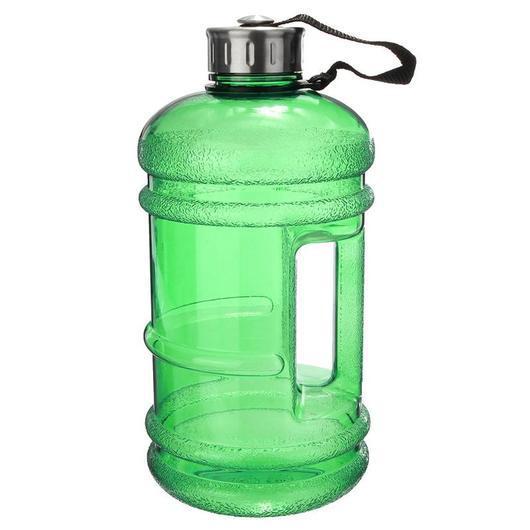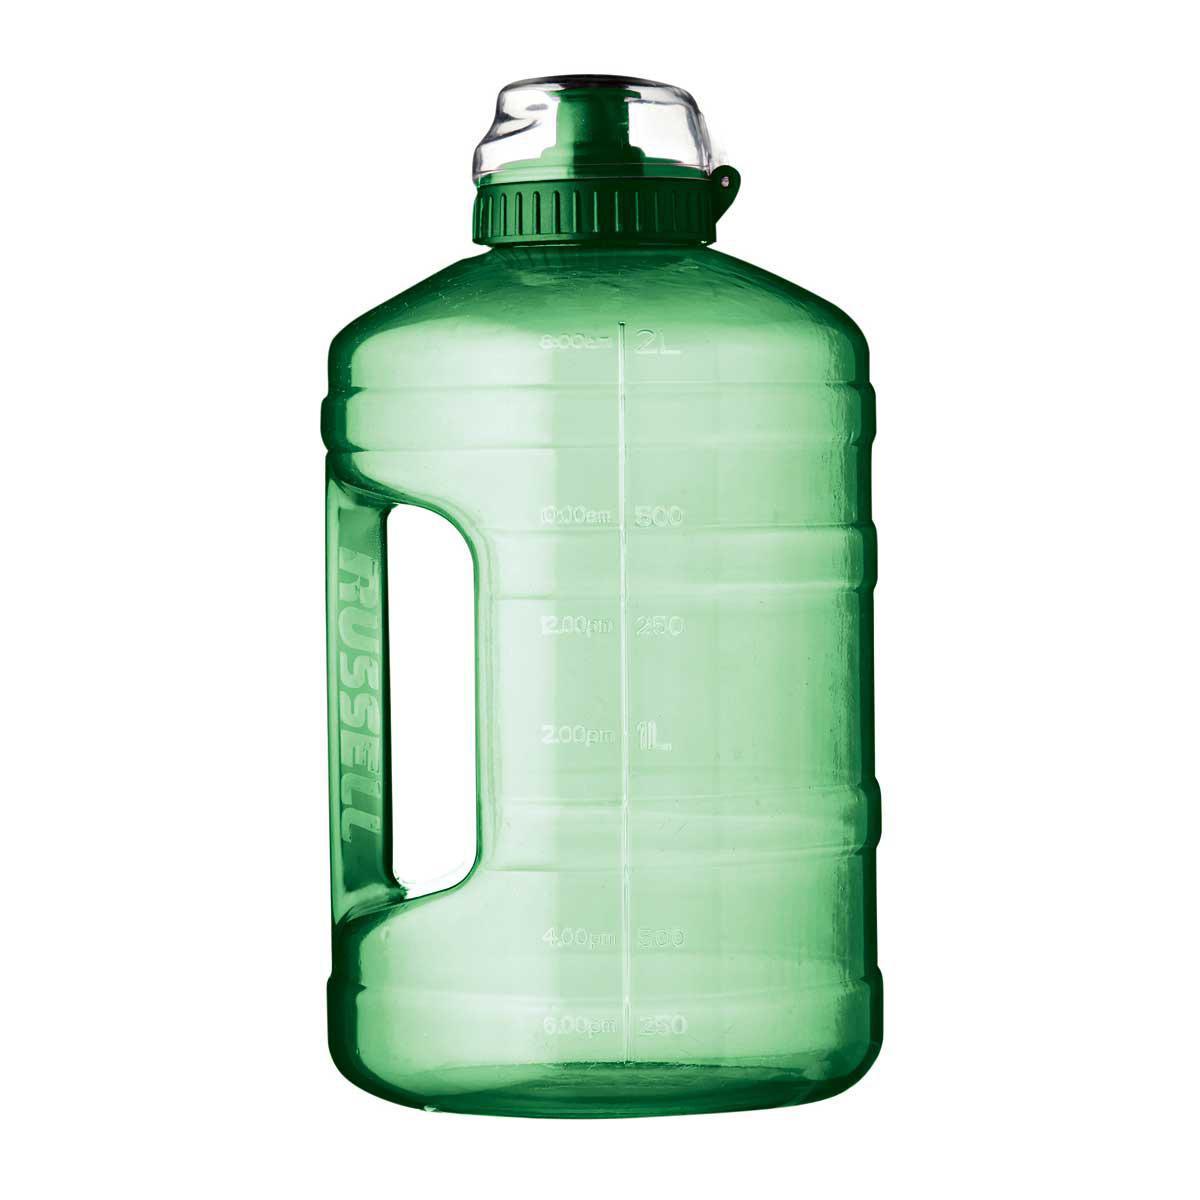The first image is the image on the left, the second image is the image on the right. Evaluate the accuracy of this statement regarding the images: "An image shows one water bottle with a black section and an indented shape.". Is it true? Answer yes or no. No. The first image is the image on the left, the second image is the image on the right. Evaluate the accuracy of this statement regarding the images: "Both of the containers are made of a clear tinted material.". Is it true? Answer yes or no. Yes. 